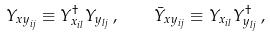<formula> <loc_0><loc_0><loc_500><loc_500>Y _ { { x y } _ { i j } } \equiv Y ^ { \dagger } _ { x _ { i l } } Y _ { y _ { l j } } \, , \quad \bar { Y } _ { x y _ { i j } } \equiv Y _ { x _ { i l } } Y ^ { \dagger } _ { y _ { l j } } \, ,</formula> 